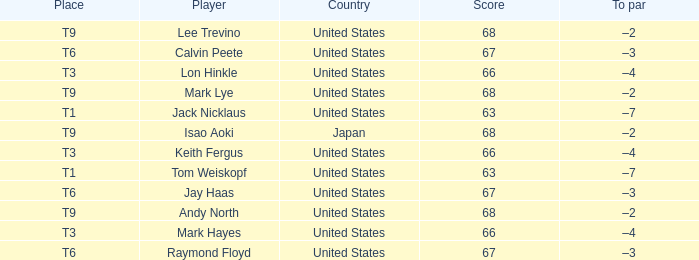When the place is identified as t6 and the player is raymond floyd, what country is being referred to? United States. 